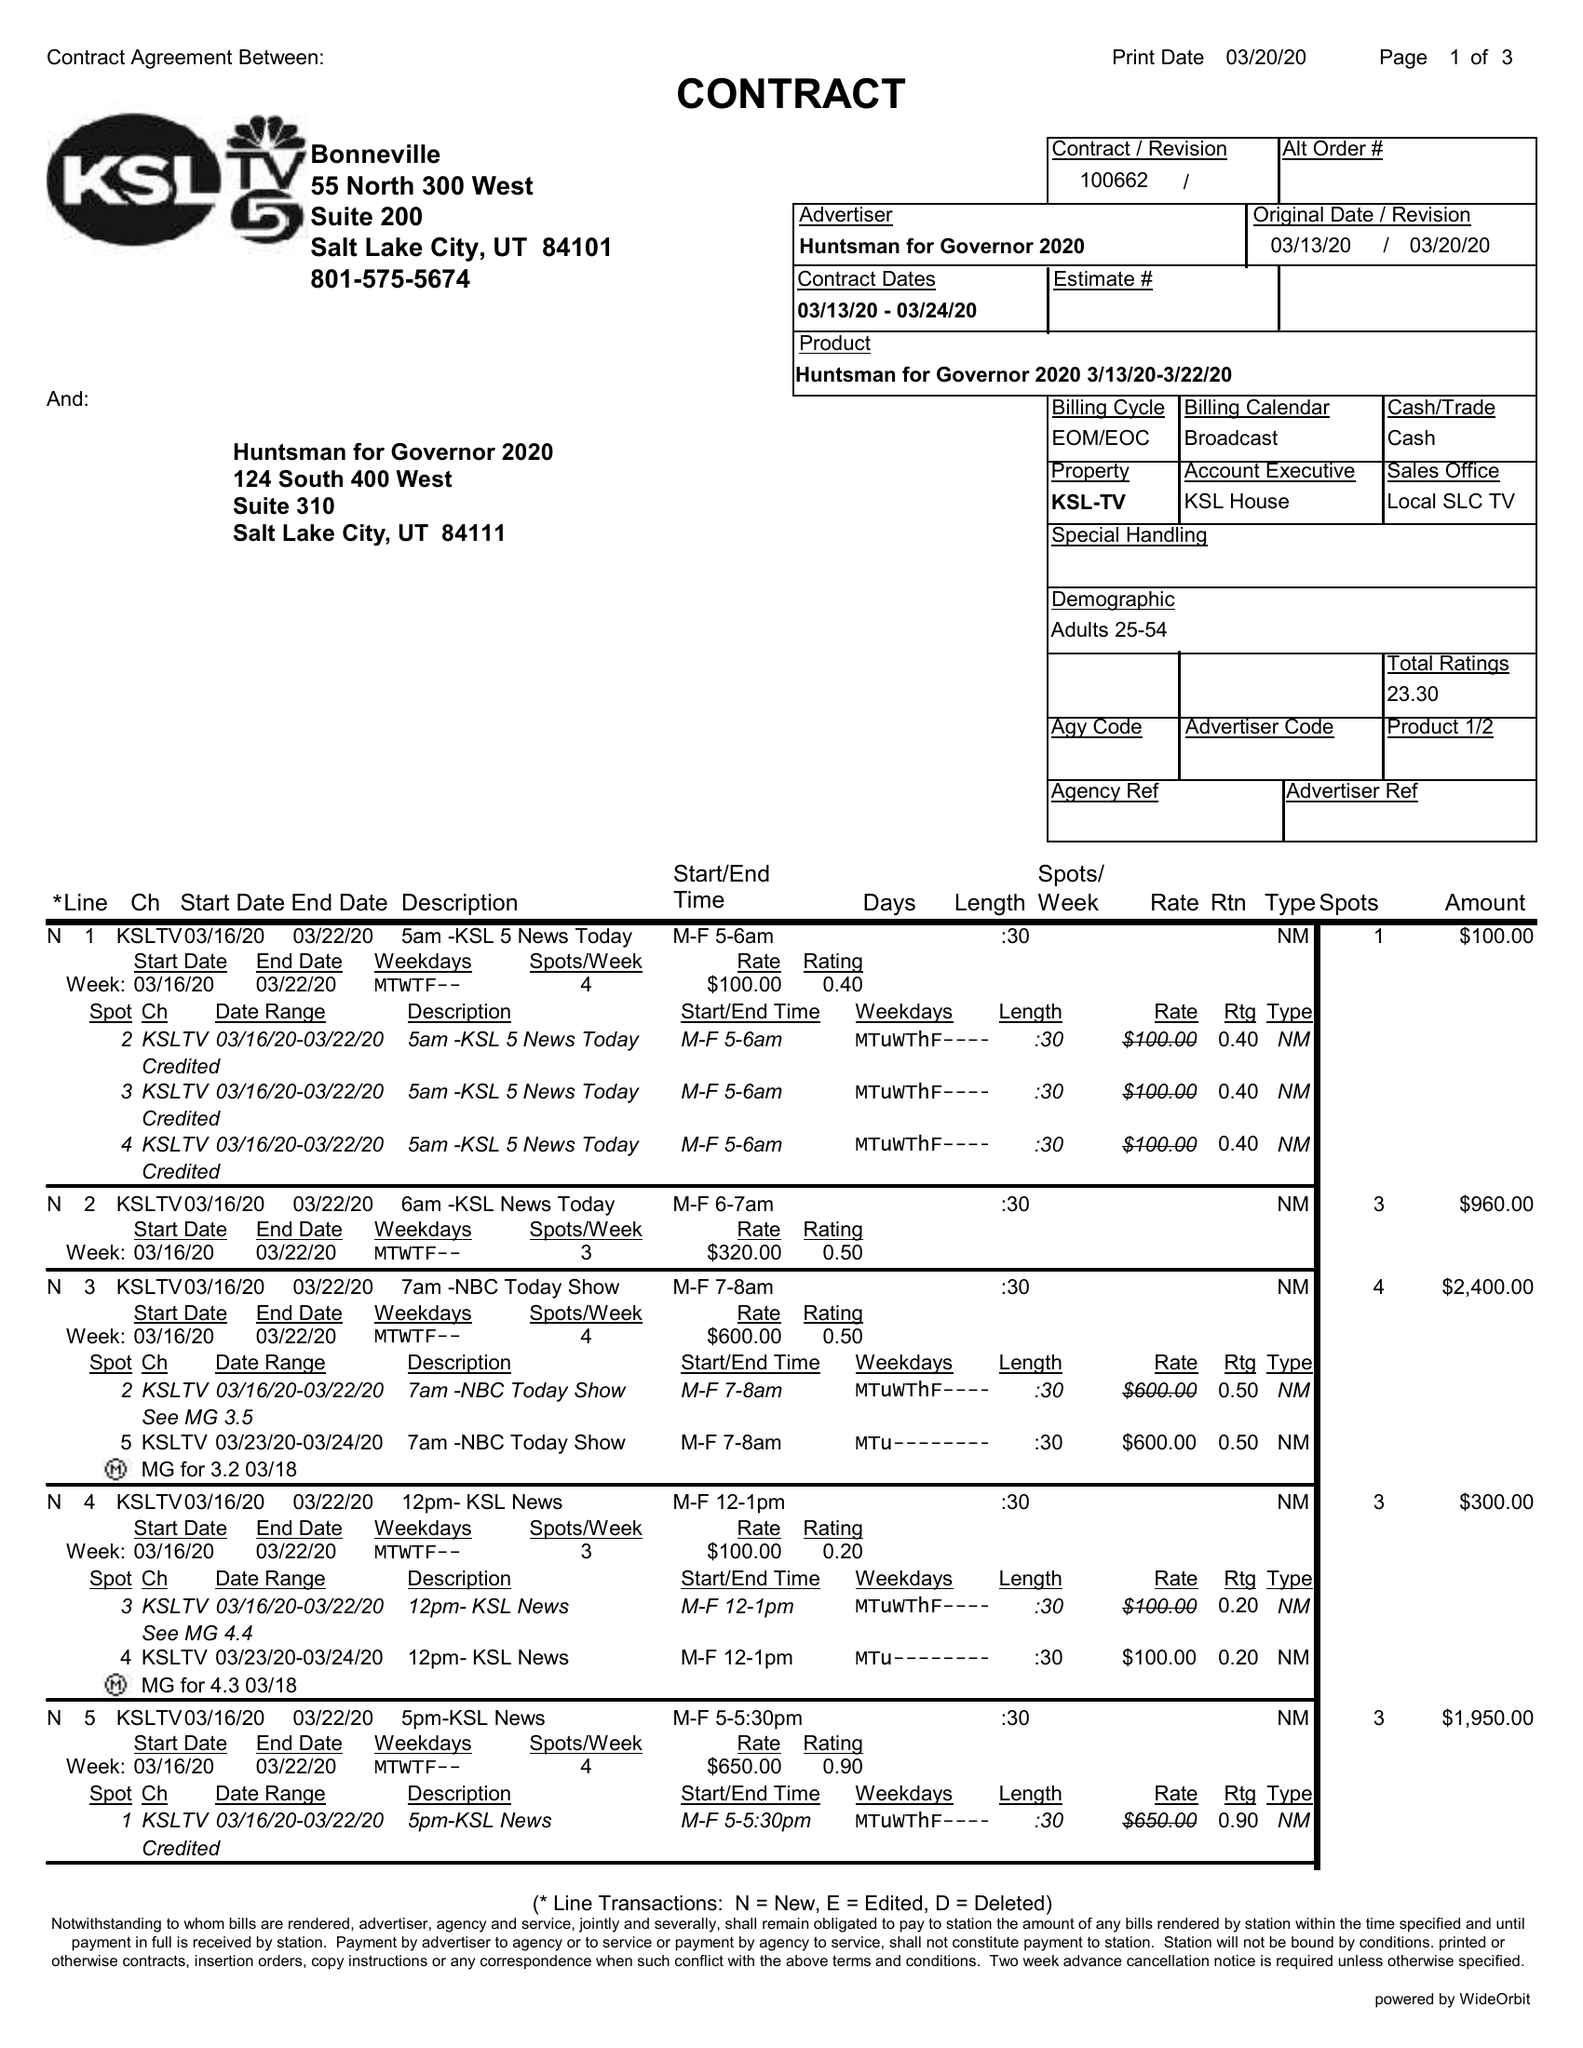What is the value for the contract_num?
Answer the question using a single word or phrase. 100662 